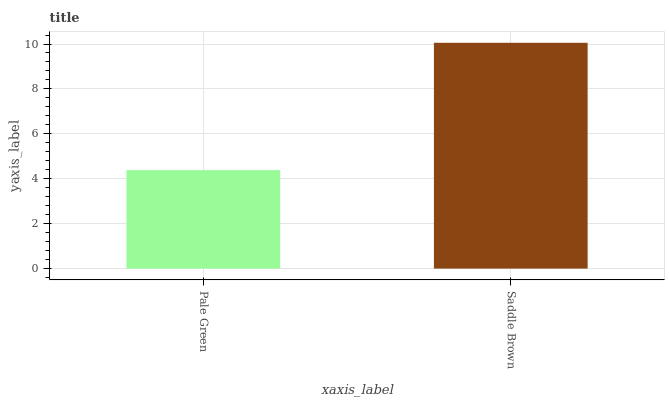Is Saddle Brown the minimum?
Answer yes or no. No. Is Saddle Brown greater than Pale Green?
Answer yes or no. Yes. Is Pale Green less than Saddle Brown?
Answer yes or no. Yes. Is Pale Green greater than Saddle Brown?
Answer yes or no. No. Is Saddle Brown less than Pale Green?
Answer yes or no. No. Is Saddle Brown the high median?
Answer yes or no. Yes. Is Pale Green the low median?
Answer yes or no. Yes. Is Pale Green the high median?
Answer yes or no. No. Is Saddle Brown the low median?
Answer yes or no. No. 